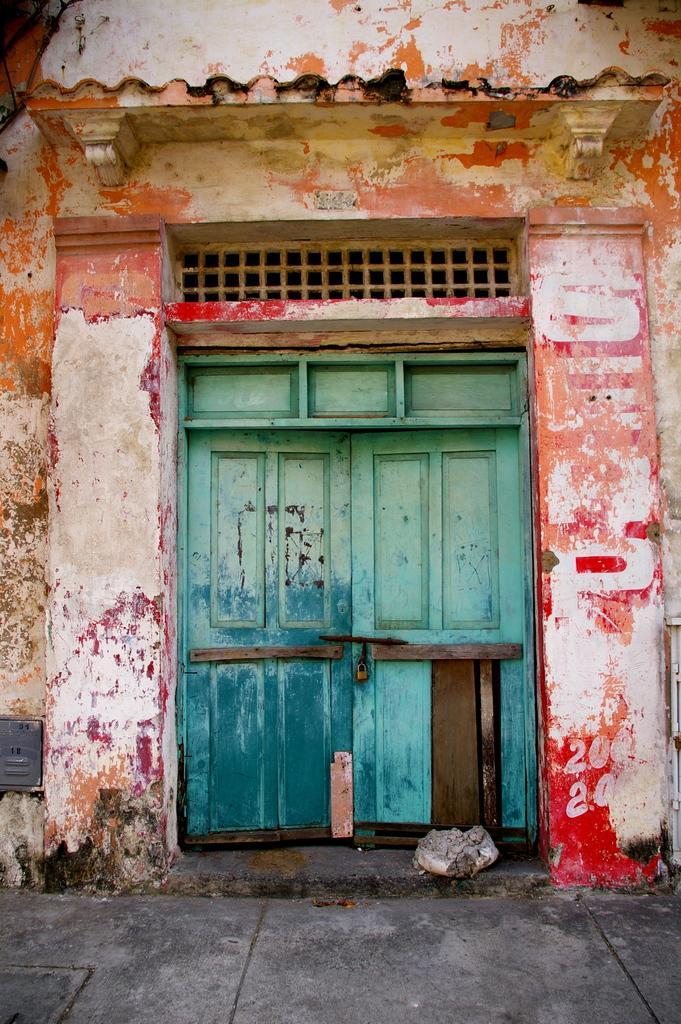In one or two sentences, can you explain what this image depicts? In the picture we can see a wooden door on the wall. 